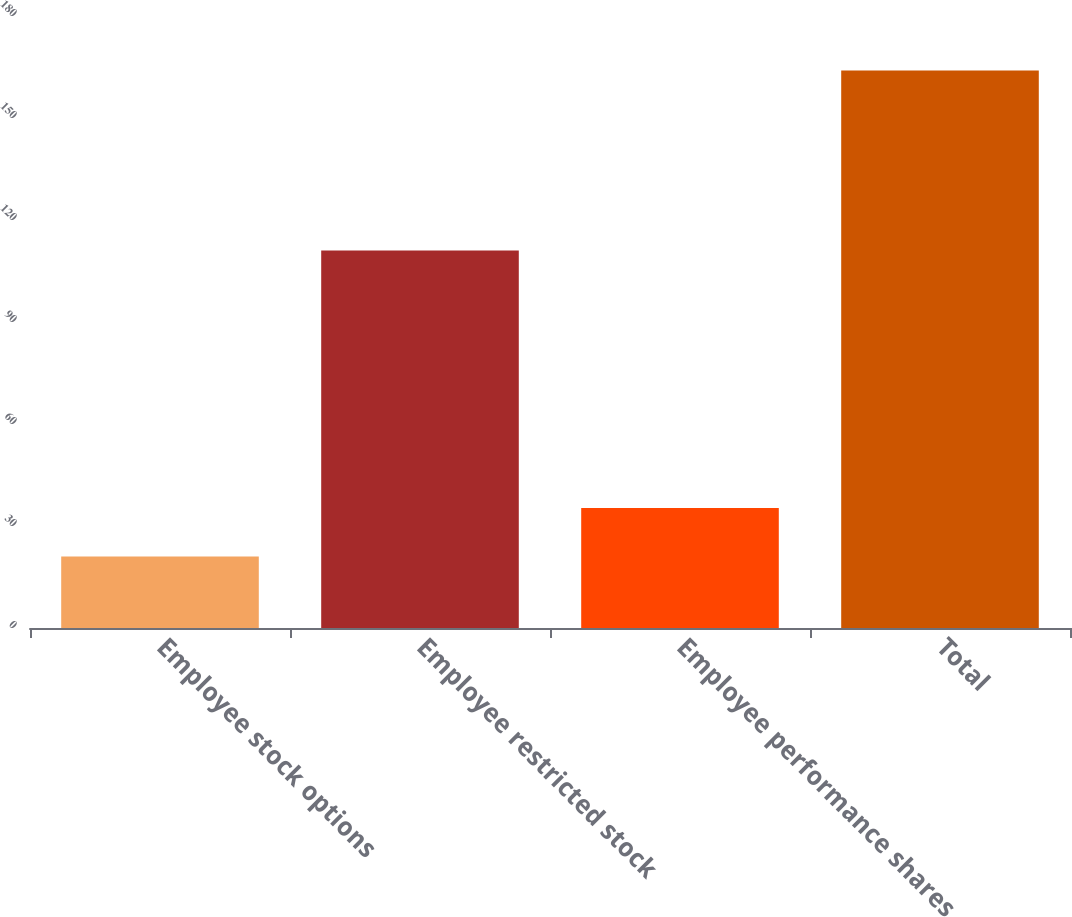<chart> <loc_0><loc_0><loc_500><loc_500><bar_chart><fcel>Employee stock options<fcel>Employee restricted stock<fcel>Employee performance shares<fcel>Total<nl><fcel>21<fcel>111<fcel>35.3<fcel>164<nl></chart> 